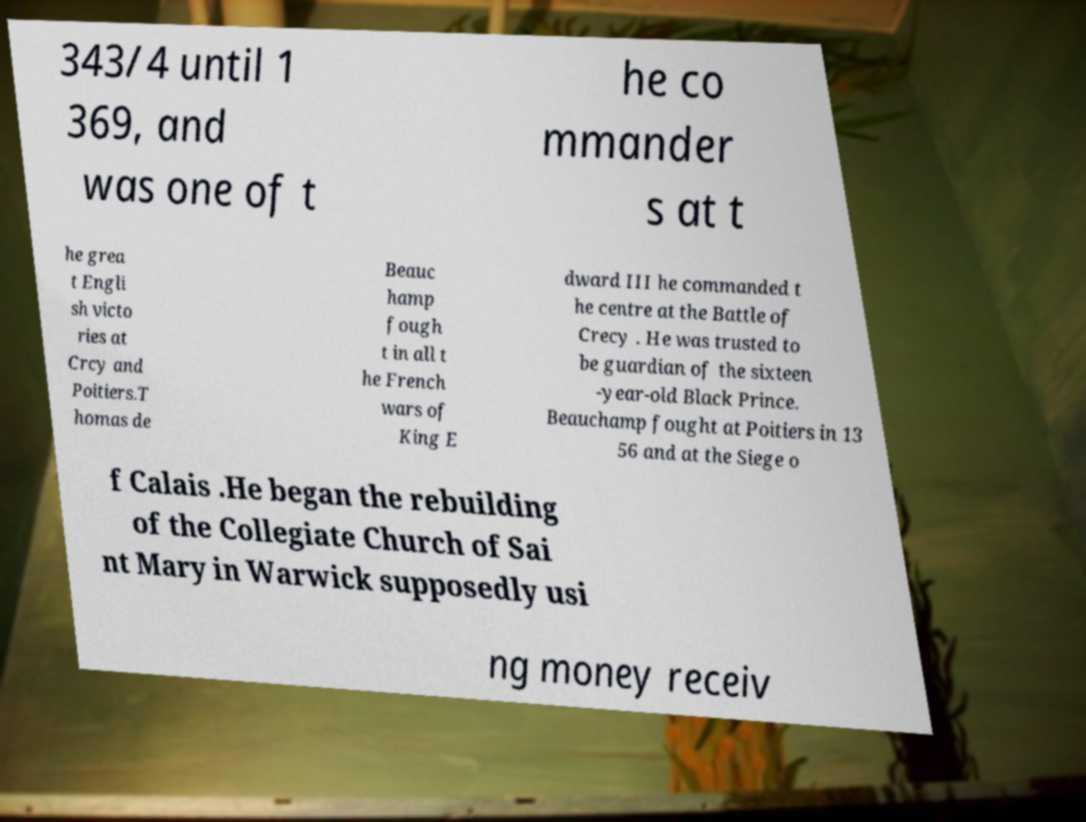Please identify and transcribe the text found in this image. 343/4 until 1 369, and was one of t he co mmander s at t he grea t Engli sh victo ries at Crcy and Poitiers.T homas de Beauc hamp fough t in all t he French wars of King E dward III he commanded t he centre at the Battle of Crecy . He was trusted to be guardian of the sixteen -year-old Black Prince. Beauchamp fought at Poitiers in 13 56 and at the Siege o f Calais .He began the rebuilding of the Collegiate Church of Sai nt Mary in Warwick supposedly usi ng money receiv 